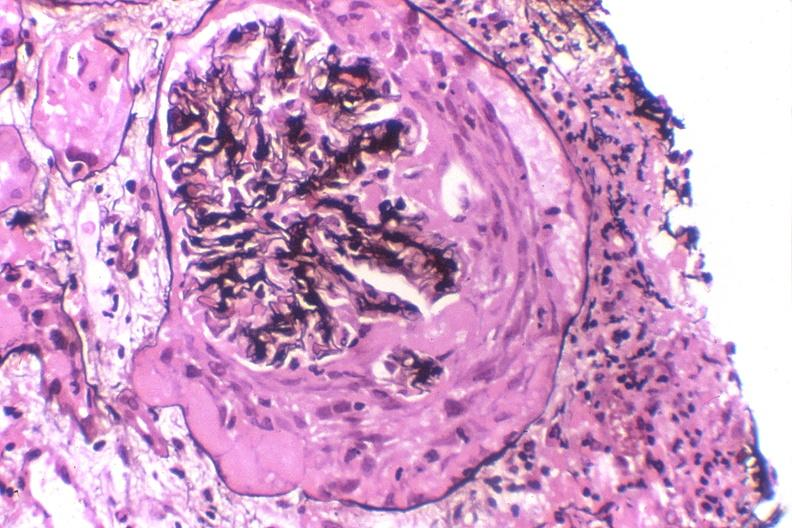s urinary present?
Answer the question using a single word or phrase. Yes 